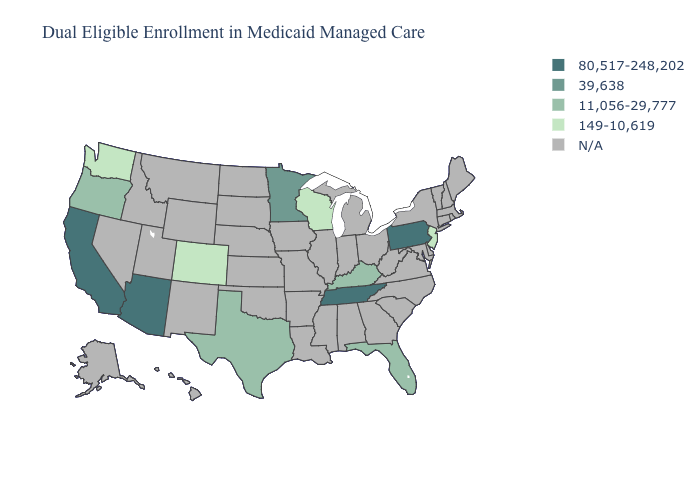Name the states that have a value in the range 80,517-248,202?
Keep it brief. Arizona, California, Pennsylvania, Tennessee. Is the legend a continuous bar?
Concise answer only. No. Name the states that have a value in the range 39,638?
Concise answer only. Minnesota. Among the states that border Nevada , which have the lowest value?
Keep it brief. Oregon. What is the value of Wisconsin?
Concise answer only. 149-10,619. What is the value of Oklahoma?
Give a very brief answer. N/A. Name the states that have a value in the range 80,517-248,202?
Concise answer only. Arizona, California, Pennsylvania, Tennessee. What is the value of Massachusetts?
Write a very short answer. N/A. Name the states that have a value in the range 11,056-29,777?
Be succinct. Florida, Kentucky, Oregon, Texas. Does Florida have the lowest value in the South?
Answer briefly. Yes. What is the value of Texas?
Be succinct. 11,056-29,777. Which states have the highest value in the USA?
Concise answer only. Arizona, California, Pennsylvania, Tennessee. What is the value of South Dakota?
Short answer required. N/A. 